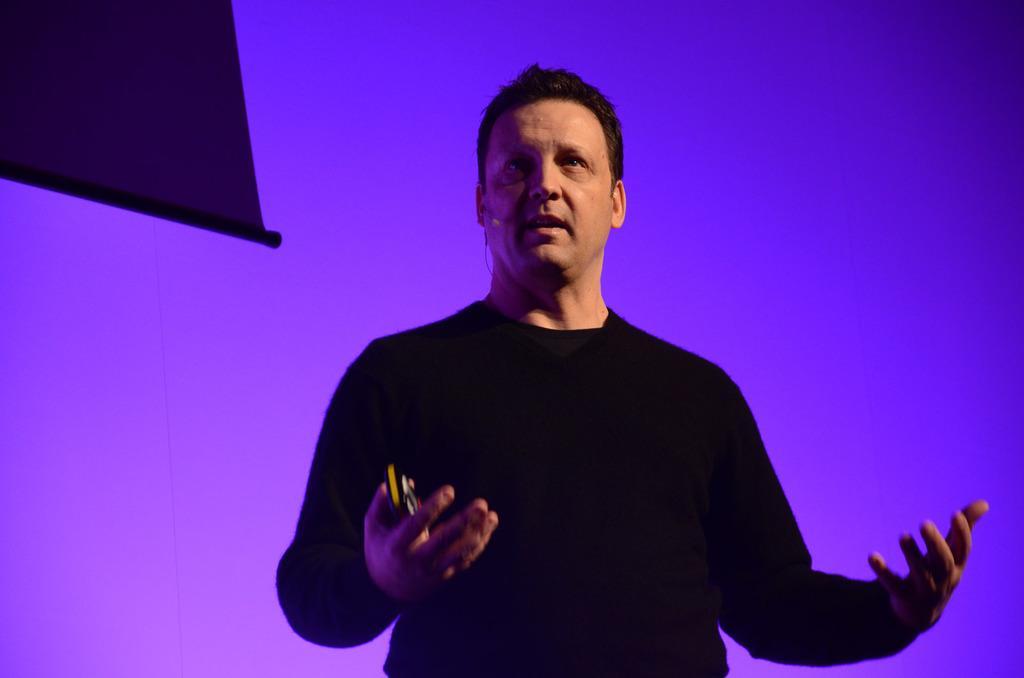Can you describe this image briefly? In this image, I can see a person is holding some object in hand. In the background, I can see a board, purple and blue color. This image is taken, maybe in a hall. 